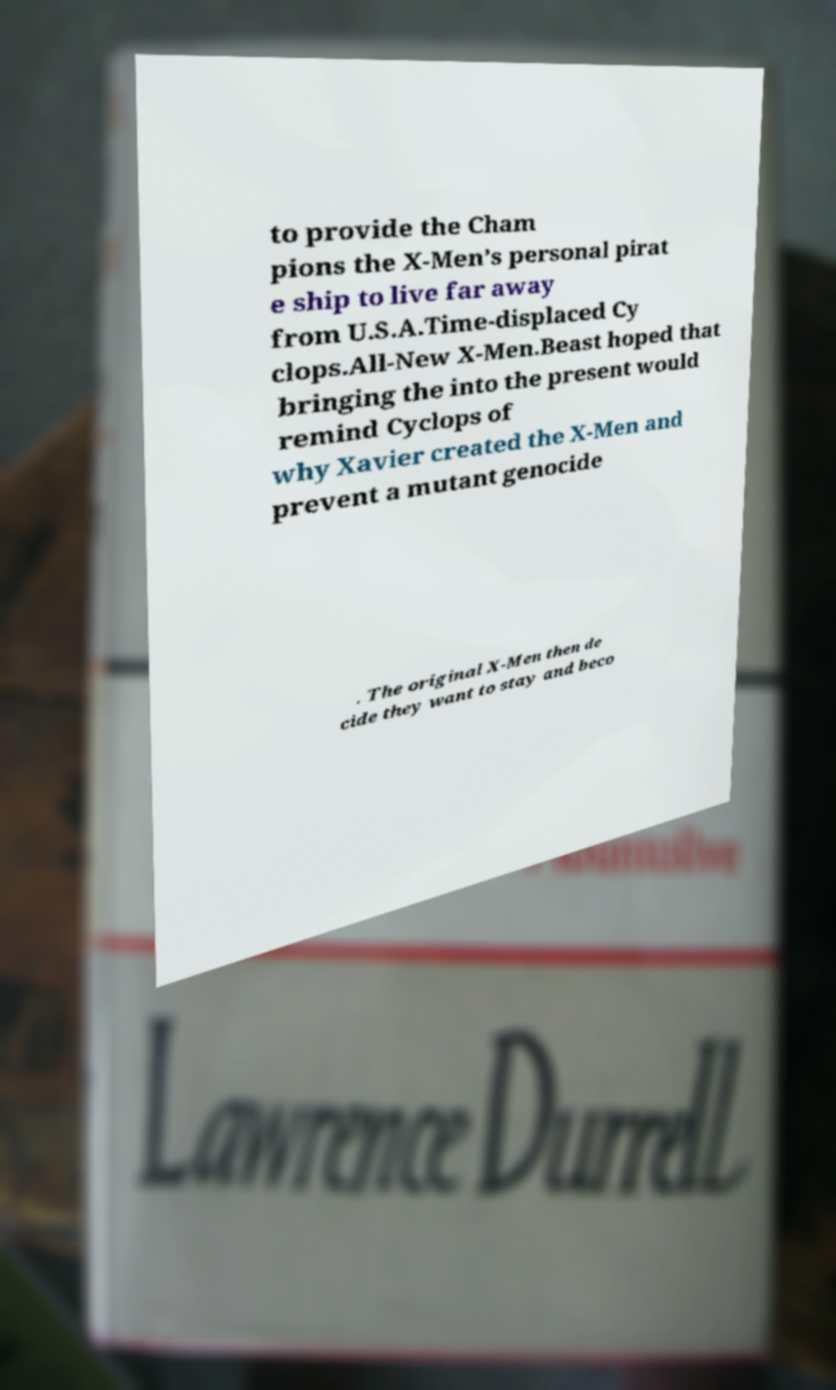Can you read and provide the text displayed in the image?This photo seems to have some interesting text. Can you extract and type it out for me? to provide the Cham pions the X-Men’s personal pirat e ship to live far away from U.S.A.Time-displaced Cy clops.All-New X-Men.Beast hoped that bringing the into the present would remind Cyclops of why Xavier created the X-Men and prevent a mutant genocide . The original X-Men then de cide they want to stay and beco 